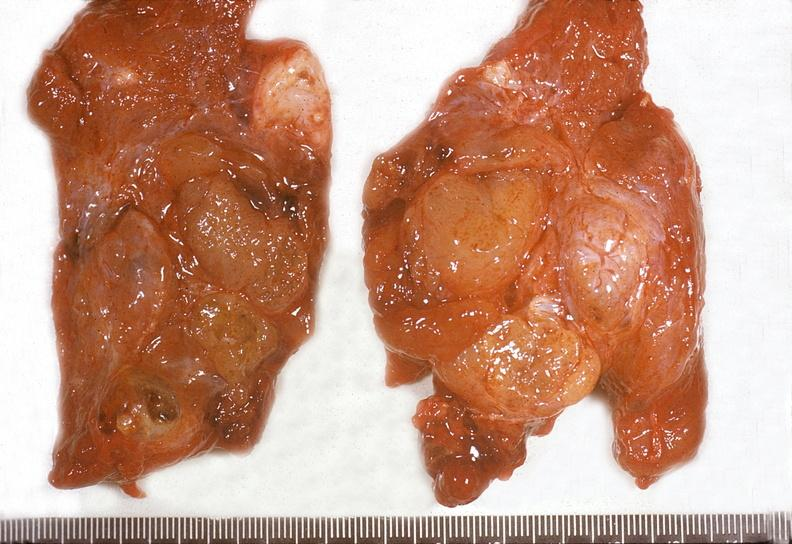does myocardium show thyroid, adenomatous goiter?
Answer the question using a single word or phrase. No 